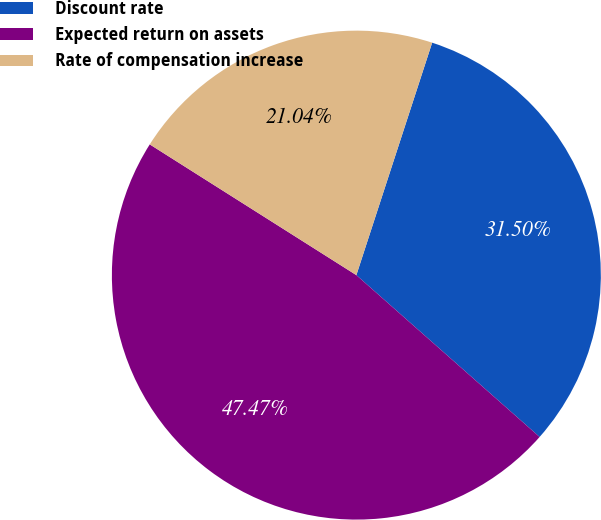Convert chart to OTSL. <chart><loc_0><loc_0><loc_500><loc_500><pie_chart><fcel>Discount rate<fcel>Expected return on assets<fcel>Rate of compensation increase<nl><fcel>31.5%<fcel>47.47%<fcel>21.04%<nl></chart> 